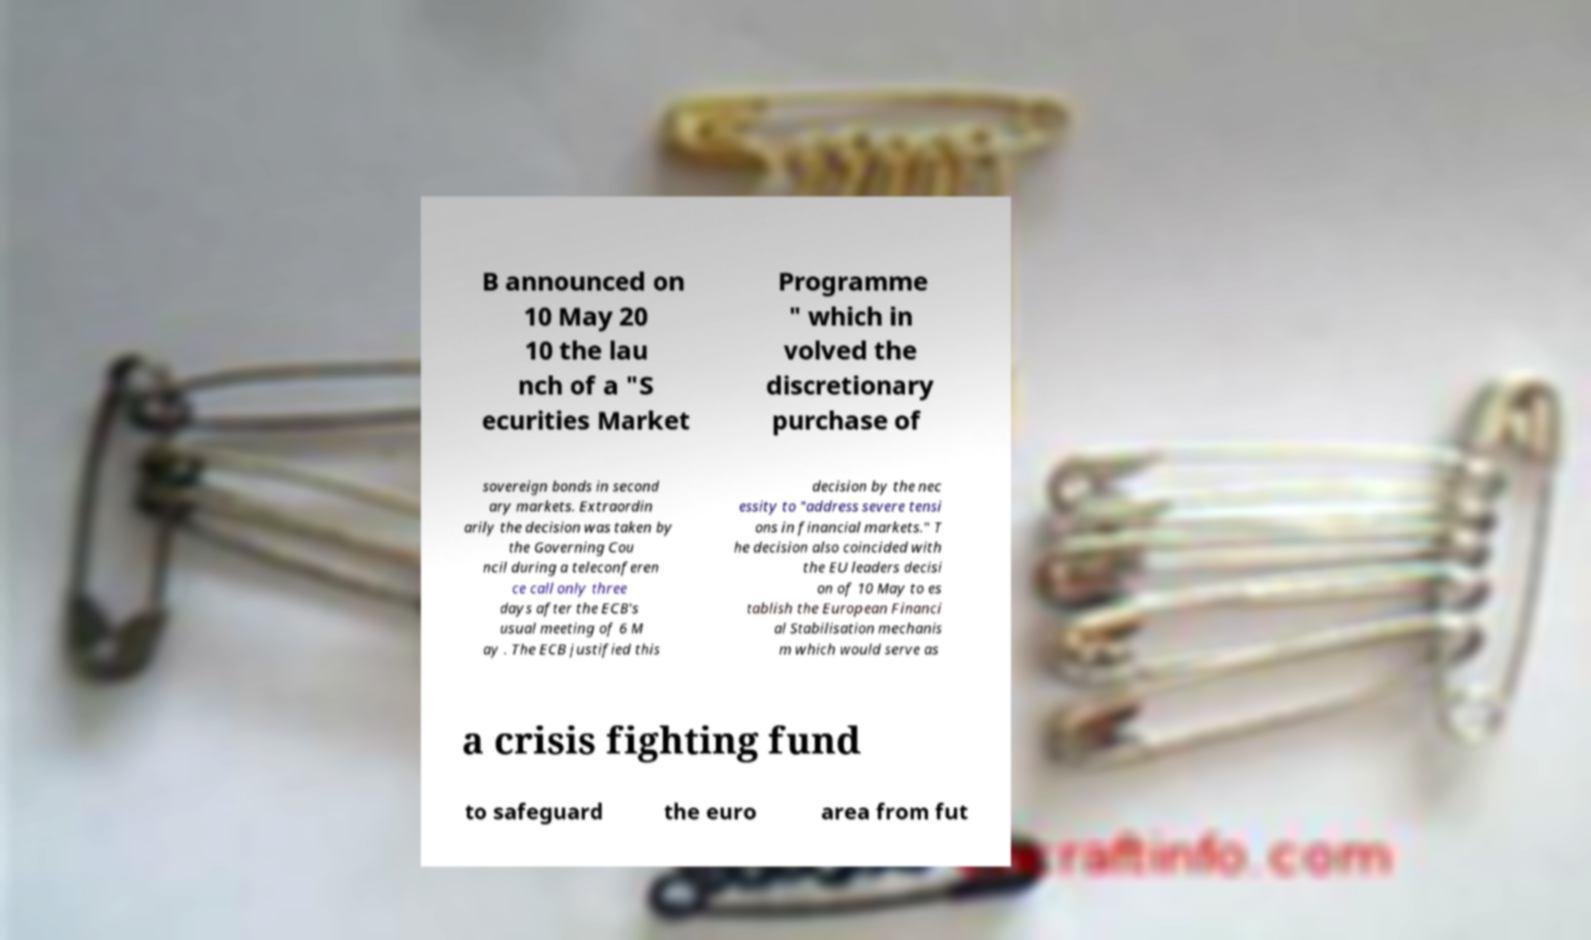Please identify and transcribe the text found in this image. B announced on 10 May 20 10 the lau nch of a "S ecurities Market Programme " which in volved the discretionary purchase of sovereign bonds in second ary markets. Extraordin arily the decision was taken by the Governing Cou ncil during a teleconferen ce call only three days after the ECB's usual meeting of 6 M ay . The ECB justified this decision by the nec essity to "address severe tensi ons in financial markets." T he decision also coincided with the EU leaders decisi on of 10 May to es tablish the European Financi al Stabilisation mechanis m which would serve as a crisis fighting fund to safeguard the euro area from fut 